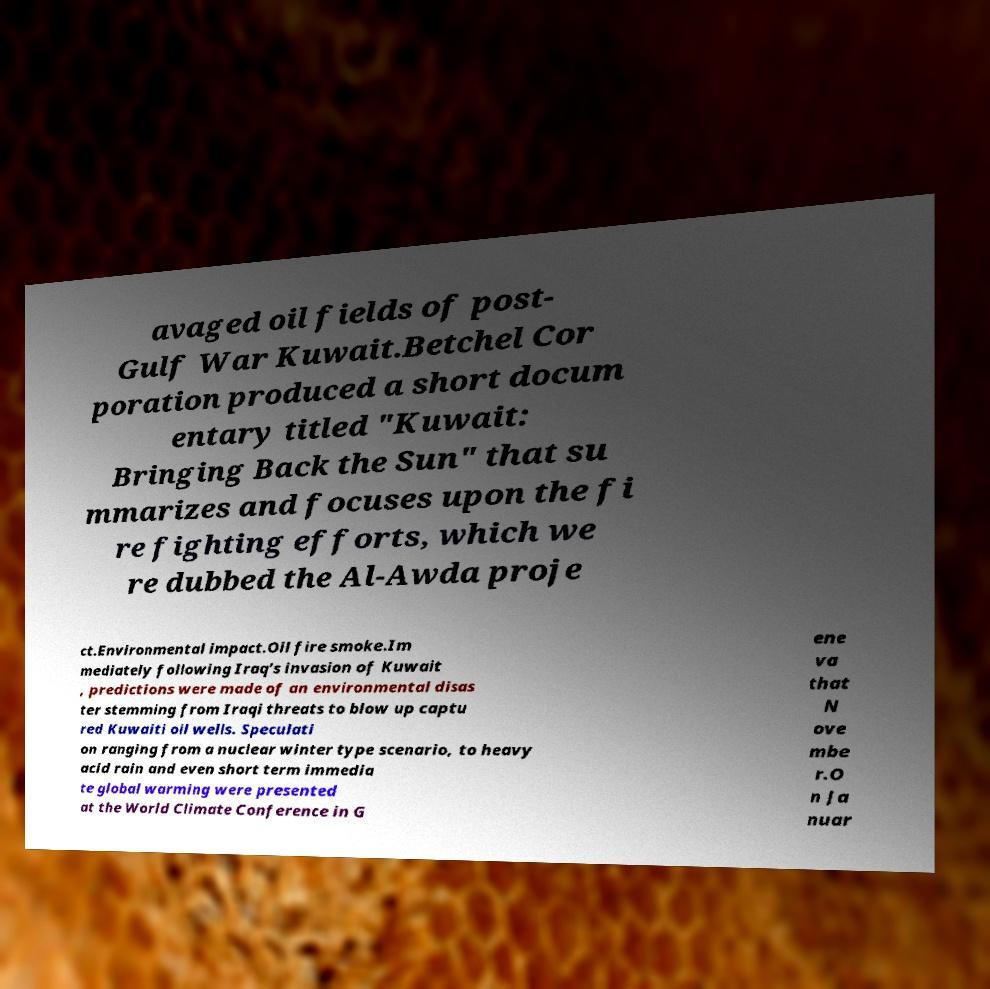Could you extract and type out the text from this image? avaged oil fields of post- Gulf War Kuwait.Betchel Cor poration produced a short docum entary titled "Kuwait: Bringing Back the Sun" that su mmarizes and focuses upon the fi re fighting efforts, which we re dubbed the Al-Awda proje ct.Environmental impact.Oil fire smoke.Im mediately following Iraq’s invasion of Kuwait , predictions were made of an environmental disas ter stemming from Iraqi threats to blow up captu red Kuwaiti oil wells. Speculati on ranging from a nuclear winter type scenario, to heavy acid rain and even short term immedia te global warming were presented at the World Climate Conference in G ene va that N ove mbe r.O n Ja nuar 